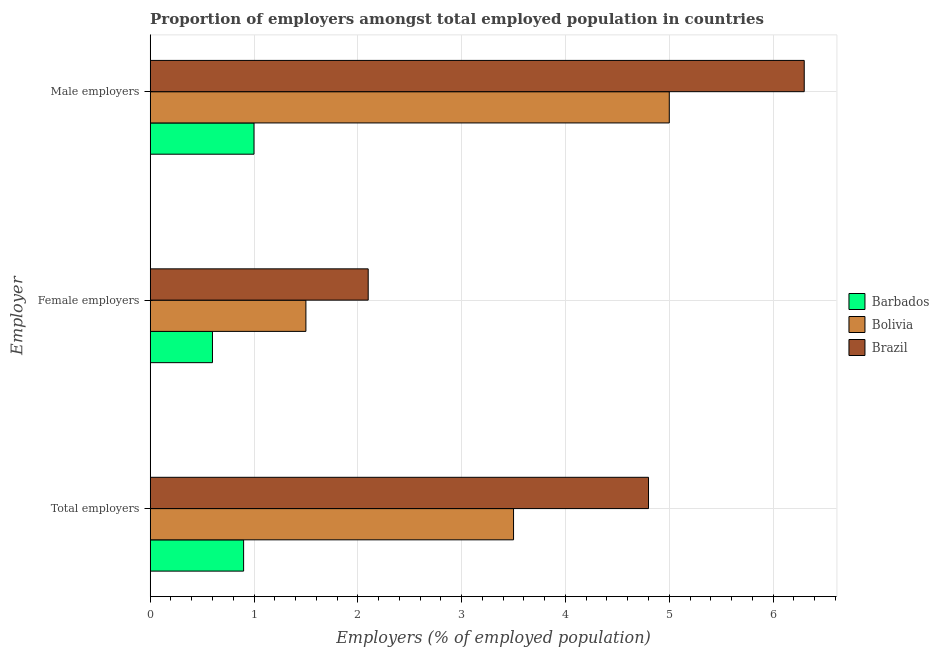How many different coloured bars are there?
Give a very brief answer. 3. How many groups of bars are there?
Offer a very short reply. 3. How many bars are there on the 3rd tick from the top?
Give a very brief answer. 3. How many bars are there on the 2nd tick from the bottom?
Your response must be concise. 3. What is the label of the 2nd group of bars from the top?
Your answer should be compact. Female employers. What is the percentage of female employers in Brazil?
Make the answer very short. 2.1. Across all countries, what is the maximum percentage of female employers?
Your answer should be compact. 2.1. Across all countries, what is the minimum percentage of total employers?
Offer a terse response. 0.9. In which country was the percentage of female employers maximum?
Offer a terse response. Brazil. In which country was the percentage of total employers minimum?
Make the answer very short. Barbados. What is the total percentage of total employers in the graph?
Offer a very short reply. 9.2. What is the difference between the percentage of total employers in Bolivia and the percentage of female employers in Brazil?
Keep it short and to the point. 1.4. What is the average percentage of total employers per country?
Offer a terse response. 3.07. What is the difference between the percentage of male employers and percentage of total employers in Barbados?
Keep it short and to the point. 0.1. In how many countries, is the percentage of female employers greater than 4.8 %?
Your response must be concise. 0. What is the ratio of the percentage of female employers in Barbados to that in Brazil?
Provide a short and direct response. 0.29. Is the percentage of total employers in Bolivia less than that in Brazil?
Ensure brevity in your answer.  Yes. What is the difference between the highest and the second highest percentage of total employers?
Make the answer very short. 1.3. What is the difference between the highest and the lowest percentage of male employers?
Make the answer very short. 5.3. What does the 3rd bar from the top in Male employers represents?
Make the answer very short. Barbados. Is it the case that in every country, the sum of the percentage of total employers and percentage of female employers is greater than the percentage of male employers?
Your answer should be compact. No. How many bars are there?
Provide a succinct answer. 9. How many countries are there in the graph?
Ensure brevity in your answer.  3. How are the legend labels stacked?
Make the answer very short. Vertical. What is the title of the graph?
Your answer should be compact. Proportion of employers amongst total employed population in countries. Does "Portugal" appear as one of the legend labels in the graph?
Make the answer very short. No. What is the label or title of the X-axis?
Give a very brief answer. Employers (% of employed population). What is the label or title of the Y-axis?
Your response must be concise. Employer. What is the Employers (% of employed population) of Barbados in Total employers?
Give a very brief answer. 0.9. What is the Employers (% of employed population) of Brazil in Total employers?
Offer a terse response. 4.8. What is the Employers (% of employed population) in Barbados in Female employers?
Provide a succinct answer. 0.6. What is the Employers (% of employed population) in Bolivia in Female employers?
Your response must be concise. 1.5. What is the Employers (% of employed population) of Brazil in Female employers?
Provide a short and direct response. 2.1. What is the Employers (% of employed population) in Barbados in Male employers?
Give a very brief answer. 1. What is the Employers (% of employed population) of Bolivia in Male employers?
Give a very brief answer. 5. What is the Employers (% of employed population) of Brazil in Male employers?
Offer a very short reply. 6.3. Across all Employer, what is the maximum Employers (% of employed population) in Brazil?
Make the answer very short. 6.3. Across all Employer, what is the minimum Employers (% of employed population) in Barbados?
Provide a succinct answer. 0.6. Across all Employer, what is the minimum Employers (% of employed population) in Bolivia?
Offer a very short reply. 1.5. Across all Employer, what is the minimum Employers (% of employed population) of Brazil?
Ensure brevity in your answer.  2.1. What is the difference between the Employers (% of employed population) in Barbados in Total employers and that in Female employers?
Offer a terse response. 0.3. What is the difference between the Employers (% of employed population) of Brazil in Total employers and that in Female employers?
Keep it short and to the point. 2.7. What is the difference between the Employers (% of employed population) in Barbados in Total employers and that in Male employers?
Keep it short and to the point. -0.1. What is the difference between the Employers (% of employed population) of Bolivia in Total employers and that in Male employers?
Keep it short and to the point. -1.5. What is the difference between the Employers (% of employed population) of Barbados in Total employers and the Employers (% of employed population) of Bolivia in Female employers?
Your answer should be very brief. -0.6. What is the difference between the Employers (% of employed population) of Barbados in Total employers and the Employers (% of employed population) of Bolivia in Male employers?
Provide a succinct answer. -4.1. What is the average Employers (% of employed population) of Barbados per Employer?
Offer a very short reply. 0.83. What is the average Employers (% of employed population) of Bolivia per Employer?
Offer a terse response. 3.33. What is the difference between the Employers (% of employed population) of Barbados and Employers (% of employed population) of Bolivia in Total employers?
Your answer should be very brief. -2.6. What is the difference between the Employers (% of employed population) of Barbados and Employers (% of employed population) of Brazil in Total employers?
Your response must be concise. -3.9. What is the difference between the Employers (% of employed population) in Bolivia and Employers (% of employed population) in Brazil in Total employers?
Ensure brevity in your answer.  -1.3. What is the difference between the Employers (% of employed population) of Barbados and Employers (% of employed population) of Bolivia in Female employers?
Your response must be concise. -0.9. What is the difference between the Employers (% of employed population) of Barbados and Employers (% of employed population) of Brazil in Female employers?
Offer a very short reply. -1.5. What is the difference between the Employers (% of employed population) of Bolivia and Employers (% of employed population) of Brazil in Female employers?
Your answer should be very brief. -0.6. What is the difference between the Employers (% of employed population) in Barbados and Employers (% of employed population) in Brazil in Male employers?
Provide a succinct answer. -5.3. What is the difference between the Employers (% of employed population) of Bolivia and Employers (% of employed population) of Brazil in Male employers?
Ensure brevity in your answer.  -1.3. What is the ratio of the Employers (% of employed population) in Bolivia in Total employers to that in Female employers?
Offer a terse response. 2.33. What is the ratio of the Employers (% of employed population) in Brazil in Total employers to that in Female employers?
Provide a succinct answer. 2.29. What is the ratio of the Employers (% of employed population) of Brazil in Total employers to that in Male employers?
Ensure brevity in your answer.  0.76. What is the ratio of the Employers (% of employed population) in Barbados in Female employers to that in Male employers?
Offer a terse response. 0.6. What is the difference between the highest and the second highest Employers (% of employed population) in Barbados?
Ensure brevity in your answer.  0.1. What is the difference between the highest and the second highest Employers (% of employed population) of Brazil?
Your response must be concise. 1.5. What is the difference between the highest and the lowest Employers (% of employed population) in Barbados?
Offer a very short reply. 0.4. What is the difference between the highest and the lowest Employers (% of employed population) of Bolivia?
Your response must be concise. 3.5. What is the difference between the highest and the lowest Employers (% of employed population) of Brazil?
Offer a terse response. 4.2. 